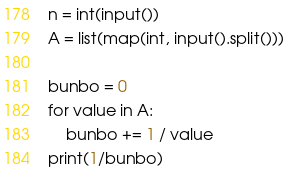Convert code to text. <code><loc_0><loc_0><loc_500><loc_500><_Python_>n = int(input())
A = list(map(int, input().split()))

bunbo = 0
for value in A:
    bunbo += 1 / value
print(1/bunbo)
</code> 